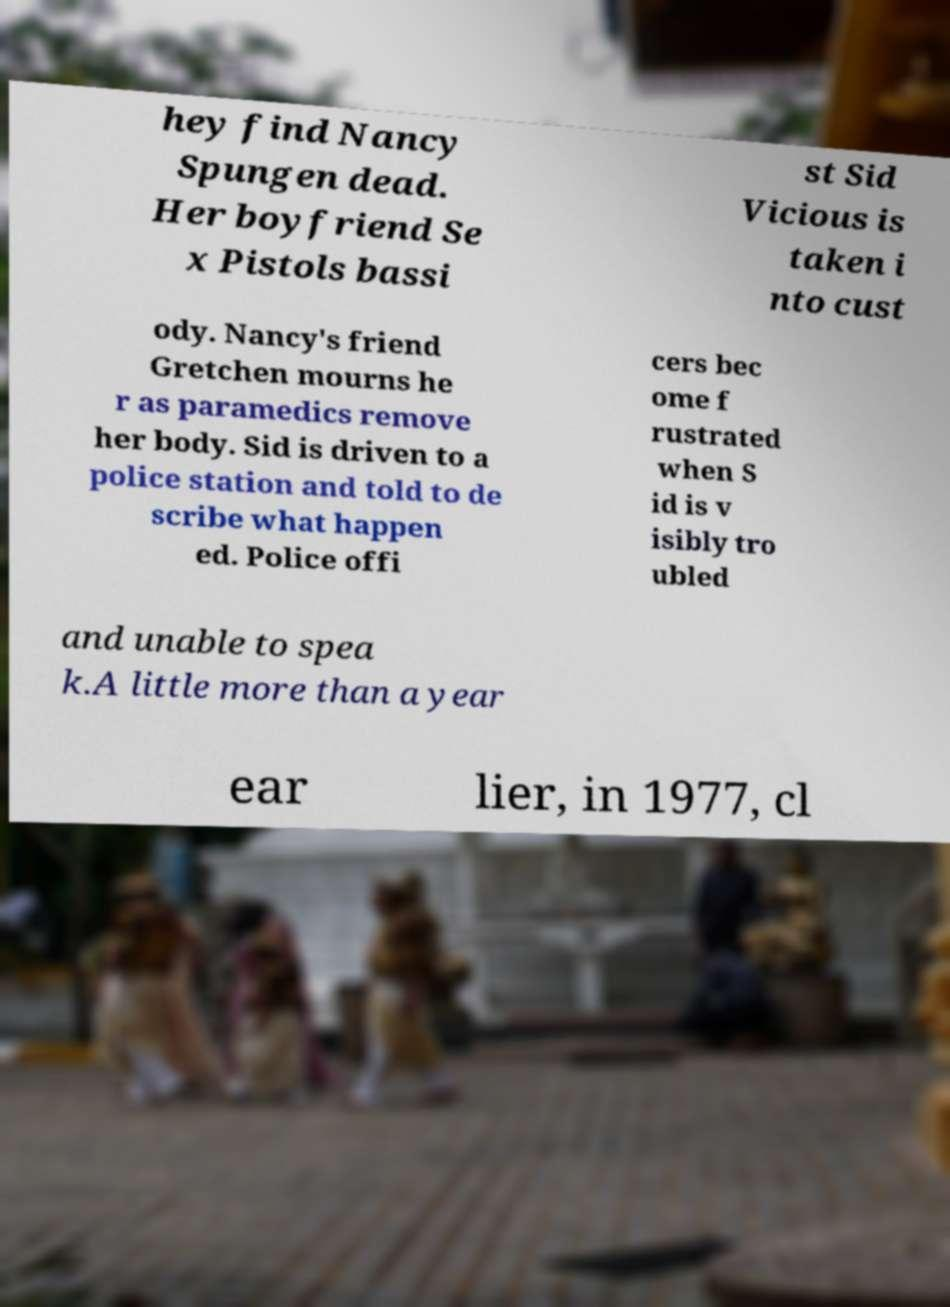Can you read and provide the text displayed in the image?This photo seems to have some interesting text. Can you extract and type it out for me? hey find Nancy Spungen dead. Her boyfriend Se x Pistols bassi st Sid Vicious is taken i nto cust ody. Nancy's friend Gretchen mourns he r as paramedics remove her body. Sid is driven to a police station and told to de scribe what happen ed. Police offi cers bec ome f rustrated when S id is v isibly tro ubled and unable to spea k.A little more than a year ear lier, in 1977, cl 